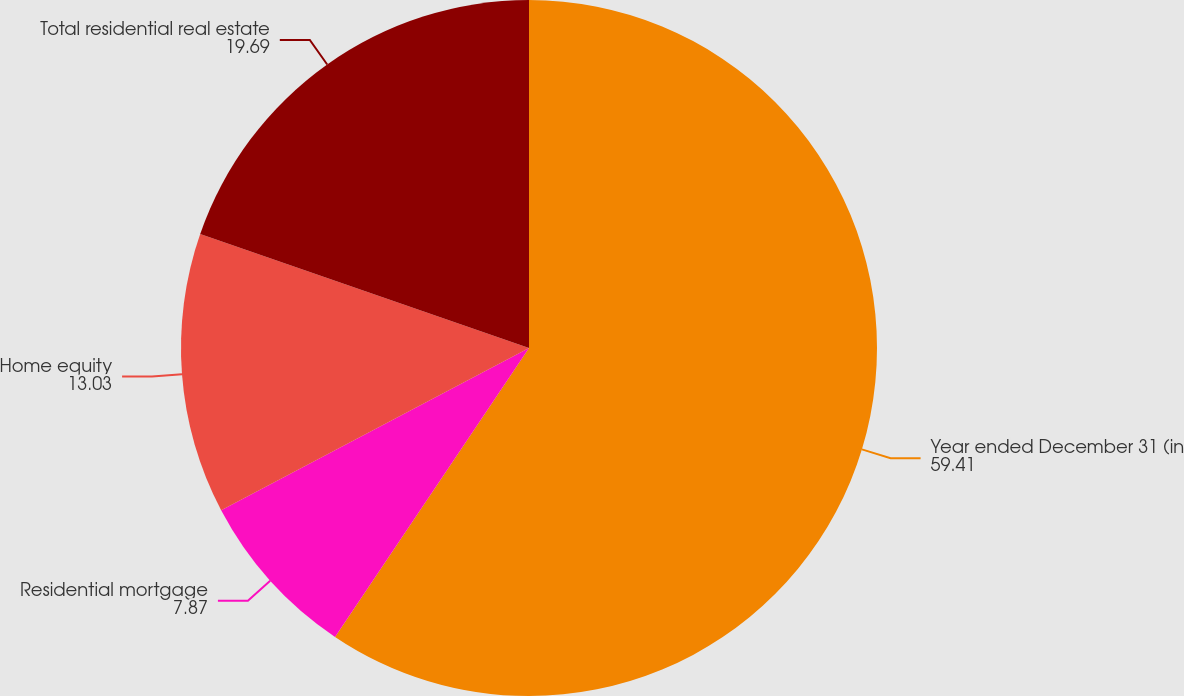<chart> <loc_0><loc_0><loc_500><loc_500><pie_chart><fcel>Year ended December 31 (in<fcel>Residential mortgage<fcel>Home equity<fcel>Total residential real estate<nl><fcel>59.41%<fcel>7.87%<fcel>13.03%<fcel>19.69%<nl></chart> 